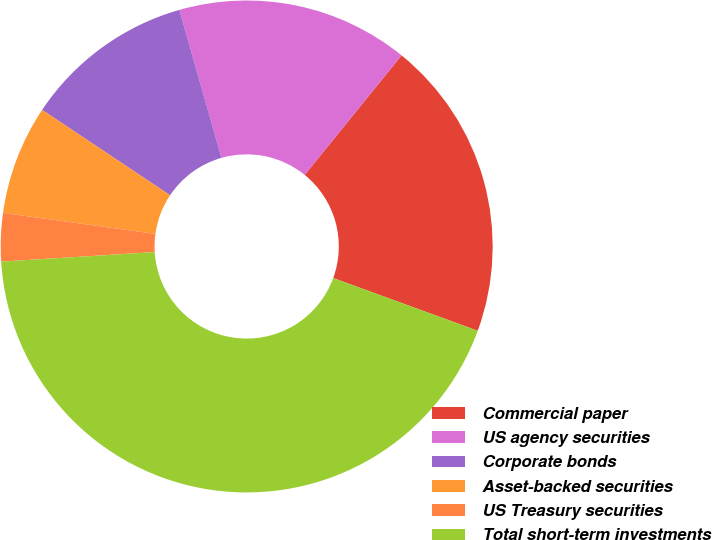Convert chart to OTSL. <chart><loc_0><loc_0><loc_500><loc_500><pie_chart><fcel>Commercial paper<fcel>US agency securities<fcel>Corporate bonds<fcel>Asset-backed securities<fcel>US Treasury securities<fcel>Total short-term investments<nl><fcel>19.73%<fcel>15.25%<fcel>11.22%<fcel>7.19%<fcel>3.16%<fcel>43.45%<nl></chart> 